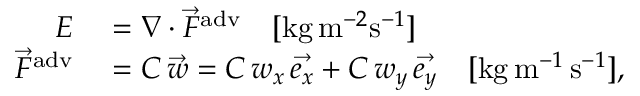<formula> <loc_0><loc_0><loc_500><loc_500>\begin{array} { r l } { E } & = \nabla \cdot \vec { F } ^ { a d v } \quad [ k g \, m ^ { - 2 } s ^ { - 1 } ] } \\ { \vec { F } ^ { a d v } } & = C \, \vec { w } = C \, w _ { x } \, \vec { e _ { x } } + C \, w _ { y } \, \vec { e _ { y } } \quad [ k g \, m ^ { - 1 } \, s ^ { - 1 } ] , } \end{array}</formula> 